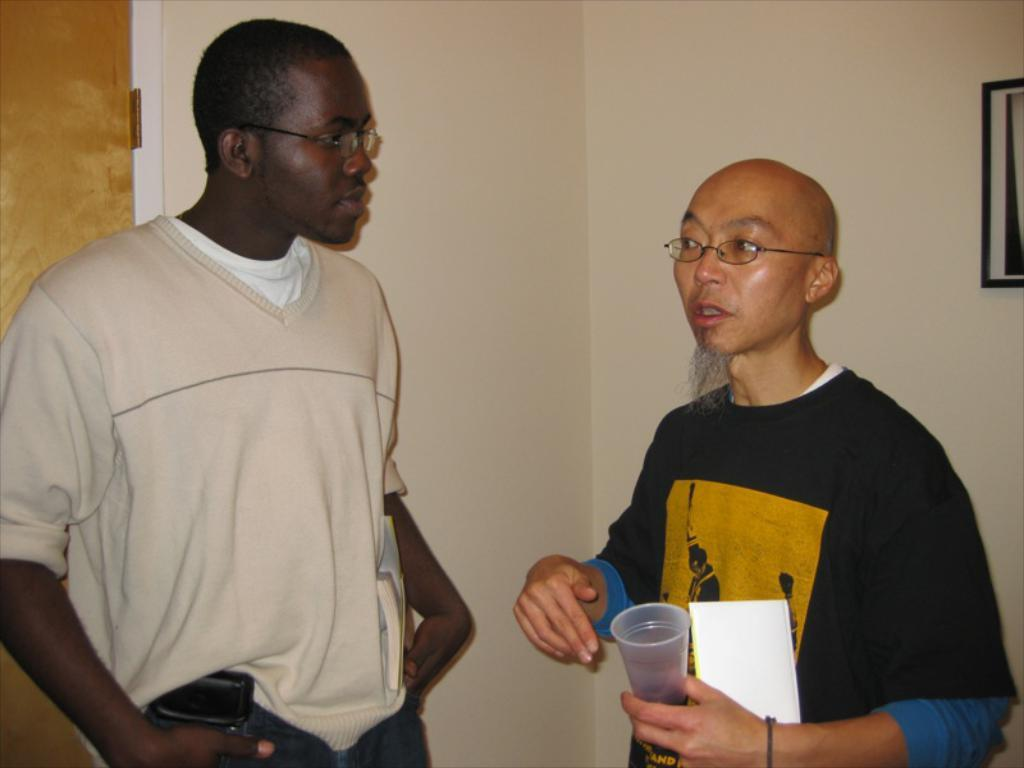How many people are in the image? There are two men in the image. What are the men doing in the image? The men are standing. What can be seen on the right side of the image? There is a frame on the right side of the image. What is on the left side of the image? There is a door on the left side of the image. What is visible in the background of the image? There is a well in the background of the image. How many babies are playing in the lake in the image? There is no lake or babies present in the image. Is there a person sitting on the well in the background of the image? There is no person sitting on the well in the background of the image; only the well is visible. 